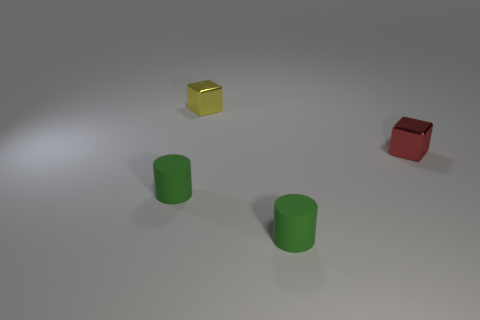What material is the small red cube that is behind the thing that is on the left side of the small shiny block that is on the left side of the red metal object?
Provide a succinct answer. Metal. What color is the object on the left side of the tiny yellow thing?
Provide a succinct answer. Green. There is a matte thing in front of the small rubber thing that is left of the small yellow metal cube; how big is it?
Keep it short and to the point. Small. Is the number of yellow metallic things that are right of the red metal object the same as the number of small yellow shiny cubes that are on the left side of the yellow shiny thing?
Offer a very short reply. Yes. What color is the other tiny block that is made of the same material as the red cube?
Ensure brevity in your answer.  Yellow. Do the small red cube and the tiny object left of the yellow shiny cube have the same material?
Your answer should be very brief. No. There is a tiny object that is in front of the red metallic thing and on the right side of the tiny yellow cube; what color is it?
Offer a terse response. Green. How many cylinders are either small objects or red objects?
Provide a succinct answer. 2. Does the tiny red thing have the same shape as the green object that is on the right side of the yellow cube?
Your answer should be compact. No. There is a object that is both right of the tiny yellow metal object and on the left side of the tiny red block; what is its size?
Make the answer very short. Small. 